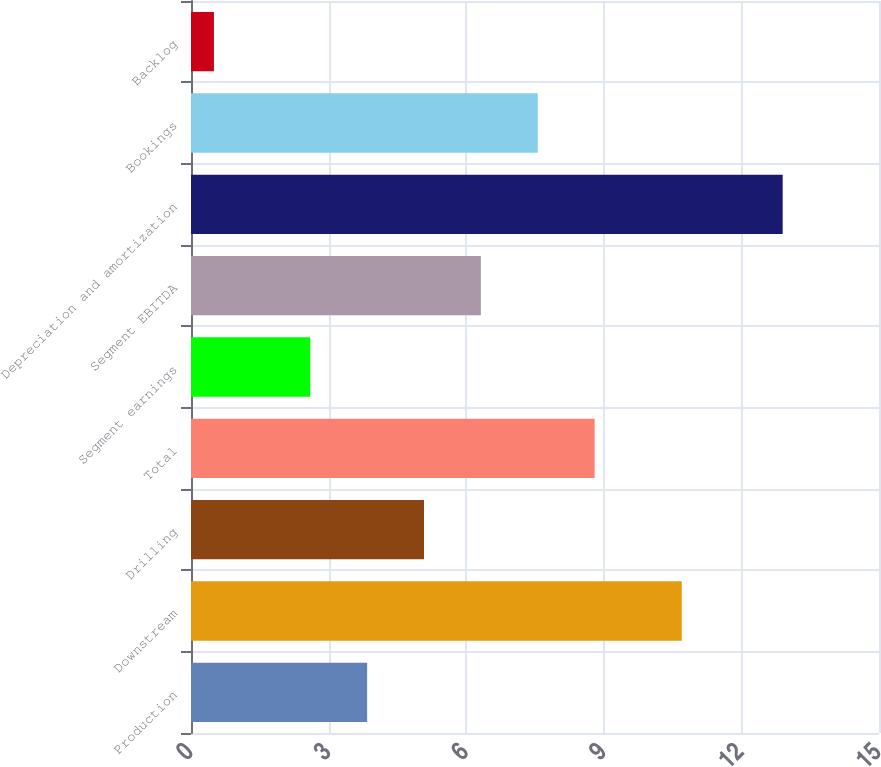<chart> <loc_0><loc_0><loc_500><loc_500><bar_chart><fcel>Production<fcel>Downstream<fcel>Drilling<fcel>Total<fcel>Segment earnings<fcel>Segment EBITDA<fcel>Depreciation and amortization<fcel>Bookings<fcel>Backlog<nl><fcel>3.84<fcel>10.7<fcel>5.08<fcel>8.8<fcel>2.6<fcel>6.32<fcel>12.9<fcel>7.56<fcel>0.5<nl></chart> 